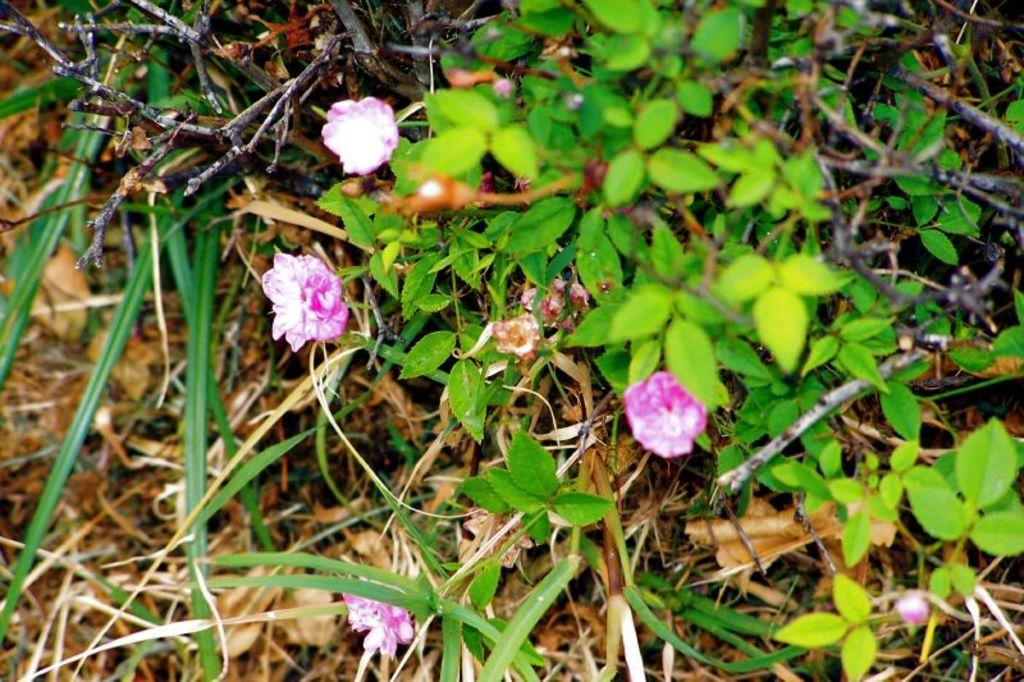What type of vegetation can be seen in the image? There are flowers and plant leaves in the image. Can you describe the flowers in the image? Unfortunately, the facts provided do not give enough detail to describe the flowers. What else is present in the image besides the flowers and plant leaves? The facts provided do not mention any other objects or elements in the image. What song is being played in the background of the image? There is no information about any song being played in the image. Can you describe the truck that is visible in the image? There is no truck present in the image; it only features flowers and plant leaves. 